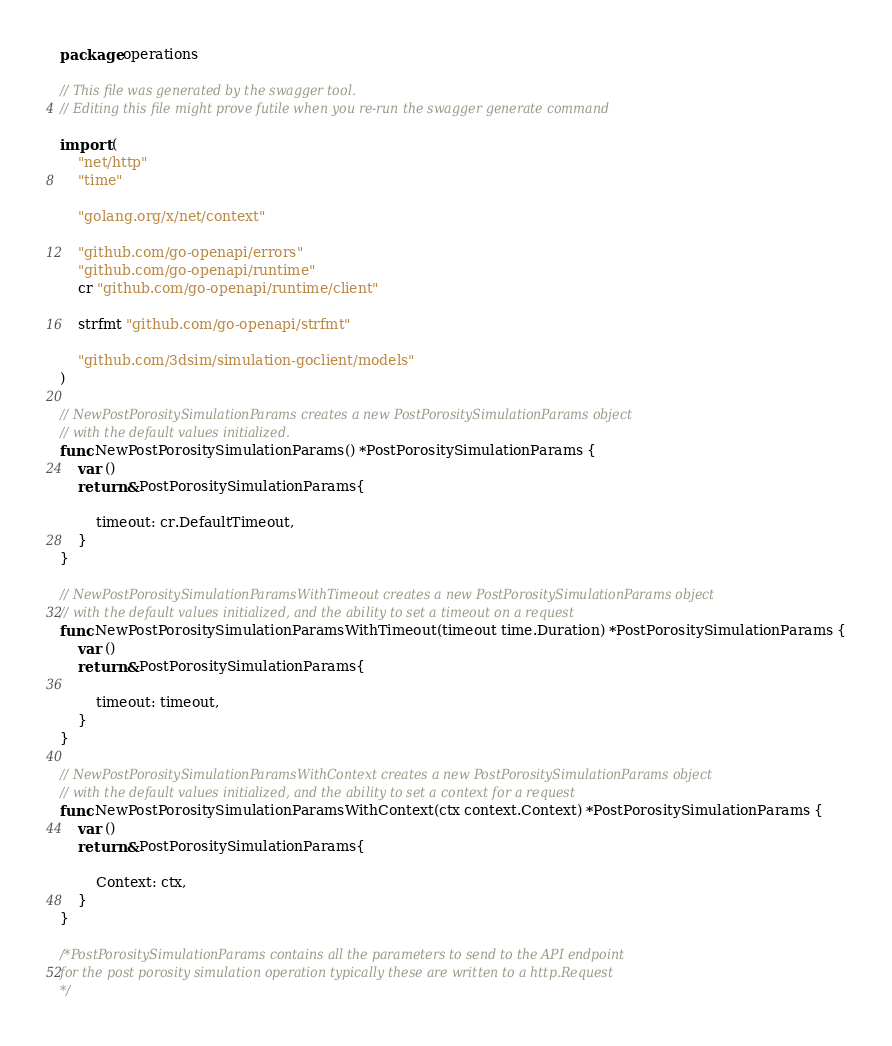<code> <loc_0><loc_0><loc_500><loc_500><_Go_>package operations

// This file was generated by the swagger tool.
// Editing this file might prove futile when you re-run the swagger generate command

import (
	"net/http"
	"time"

	"golang.org/x/net/context"

	"github.com/go-openapi/errors"
	"github.com/go-openapi/runtime"
	cr "github.com/go-openapi/runtime/client"

	strfmt "github.com/go-openapi/strfmt"

	"github.com/3dsim/simulation-goclient/models"
)

// NewPostPorositySimulationParams creates a new PostPorositySimulationParams object
// with the default values initialized.
func NewPostPorositySimulationParams() *PostPorositySimulationParams {
	var ()
	return &PostPorositySimulationParams{

		timeout: cr.DefaultTimeout,
	}
}

// NewPostPorositySimulationParamsWithTimeout creates a new PostPorositySimulationParams object
// with the default values initialized, and the ability to set a timeout on a request
func NewPostPorositySimulationParamsWithTimeout(timeout time.Duration) *PostPorositySimulationParams {
	var ()
	return &PostPorositySimulationParams{

		timeout: timeout,
	}
}

// NewPostPorositySimulationParamsWithContext creates a new PostPorositySimulationParams object
// with the default values initialized, and the ability to set a context for a request
func NewPostPorositySimulationParamsWithContext(ctx context.Context) *PostPorositySimulationParams {
	var ()
	return &PostPorositySimulationParams{

		Context: ctx,
	}
}

/*PostPorositySimulationParams contains all the parameters to send to the API endpoint
for the post porosity simulation operation typically these are written to a http.Request
*/</code> 